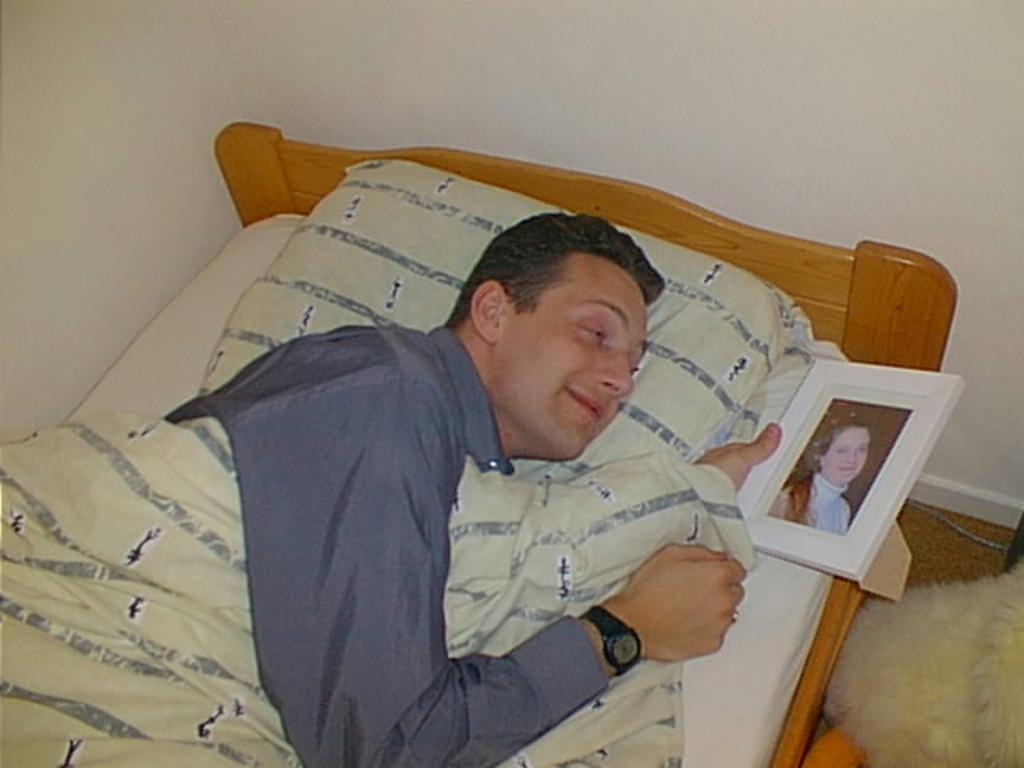Who is present in the image? There is a man in the image. What is the man doing in the image? The man is lying on a bed. What is the man holding in the image? The man is holding a frame. What type of toy can be seen in the man's hand in the image? There is no toy present in the image; the man is holding a frame. 